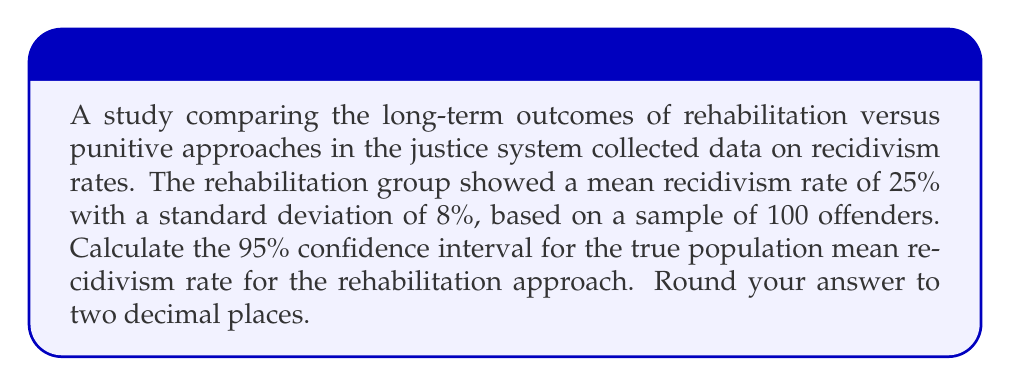Teach me how to tackle this problem. To calculate the confidence interval, we'll follow these steps:

1) The formula for a 95% confidence interval is:

   $$\bar{x} \pm (z_{0.025} \times \frac{\sigma}{\sqrt{n}})$$

   Where:
   $\bar{x}$ is the sample mean
   $z_{0.025}$ is the z-score for a 95% confidence level (1.96)
   $\sigma$ is the population standard deviation
   $n$ is the sample size

2) We know:
   $\bar{x} = 25\%$
   $\sigma = 8\%$ (we'll assume the sample standard deviation is a good estimate of the population standard deviation)
   $n = 100$
   $z_{0.025} = 1.96$

3) Let's substitute these values into our formula:

   $$25\% \pm (1.96 \times \frac{8\%}{\sqrt{100}})$$

4) Simplify:
   $$25\% \pm (1.96 \times 0.8\%)$$
   $$25\% \pm 1.568\%$$

5) Calculate the lower and upper bounds:
   Lower bound: $25\% - 1.568\% = 23.432\%$
   Upper bound: $25\% + 1.568\% = 26.568\%$

6) Rounding to two decimal places:
   Lower bound: 23.43%
   Upper bound: 26.57%
Answer: (23.43%, 26.57%) 